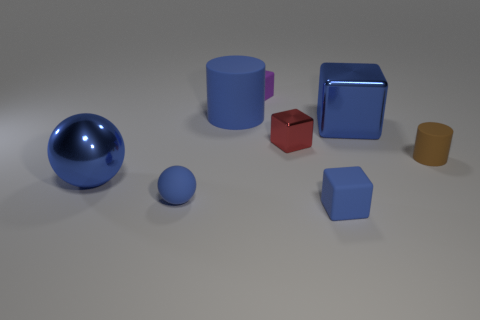The blue rubber object that is behind the big sphere has what shape?
Your answer should be compact. Cylinder. How many other objects are the same material as the big ball?
Provide a succinct answer. 2. What is the size of the brown matte thing?
Give a very brief answer. Small. How many other objects are the same color as the big cylinder?
Your answer should be very brief. 4. The small rubber object that is both left of the small metal thing and in front of the brown cylinder is what color?
Provide a short and direct response. Blue. What number of green shiny objects are there?
Your response must be concise. 0. Does the red block have the same material as the purple thing?
Your answer should be very brief. No. What shape is the large blue metal thing on the left side of the small thing that is behind the rubber cylinder that is behind the blue metal block?
Ensure brevity in your answer.  Sphere. Is the sphere that is behind the small ball made of the same material as the cylinder to the left of the purple rubber object?
Provide a short and direct response. No. What is the material of the tiny red object?
Offer a terse response. Metal. 